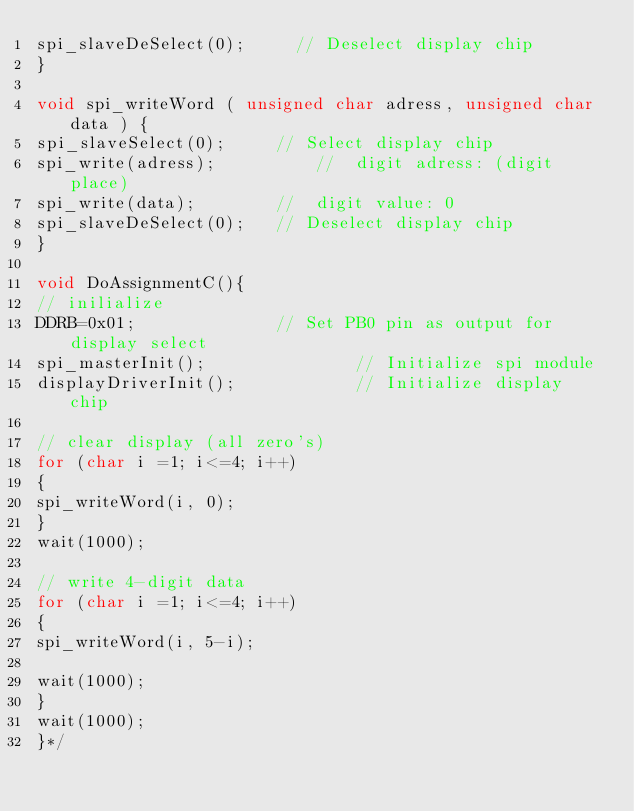Convert code to text. <code><loc_0><loc_0><loc_500><loc_500><_C_>spi_slaveDeSelect(0);			// Deselect display chip
}

void spi_writeWord ( unsigned char adress, unsigned char data ) {
spi_slaveSelect(0); 		// Select display chip
spi_write(adress);  				// 	digit adress: (digit place)
spi_write(data);				// 	digit value: 0
spi_slaveDeSelect(0);		// Deselect display chip
}

void DoAssignmentC(){
// inilialize
DDRB=0x01;					  	// Set PB0 pin as output for display select
spi_masterInit();              	// Initialize spi module
displayDriverInit();            // Initialize display chip

// clear display (all zero's)
for (char i =1; i<=4; i++)
{
spi_writeWord(i, 0);
}
wait(1000);

// write 4-digit data
for (char i =1; i<=4; i++)
{
spi_writeWord(i, 5-i);

wait(1000);
}
wait(1000);
}*/</code> 